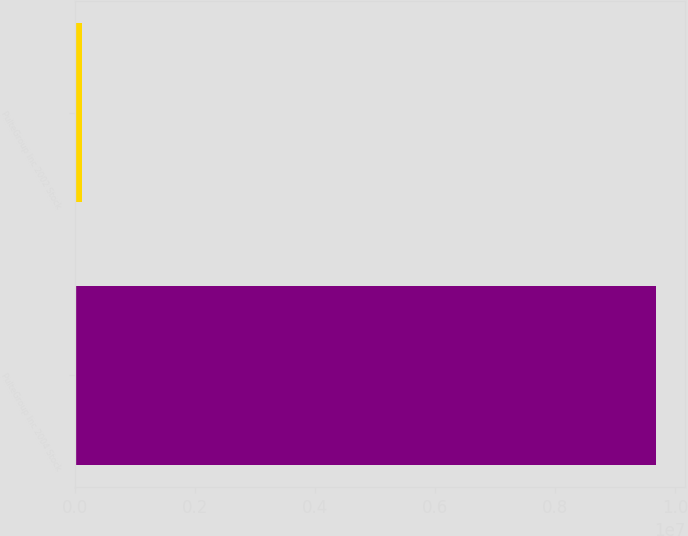Convert chart. <chart><loc_0><loc_0><loc_500><loc_500><bar_chart><fcel>PulteGroup Inc 2004 Stock<fcel>PulteGroup Inc 2002 Stock<nl><fcel>9.68421e+06<fcel>127805<nl></chart> 